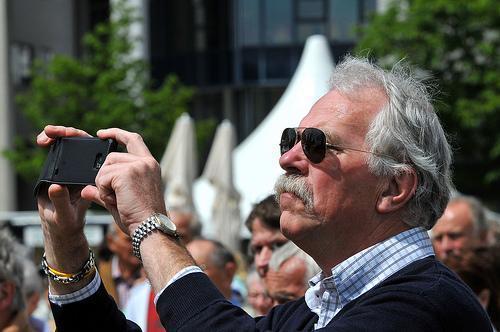How many people holding their phones?
Give a very brief answer. 1. 